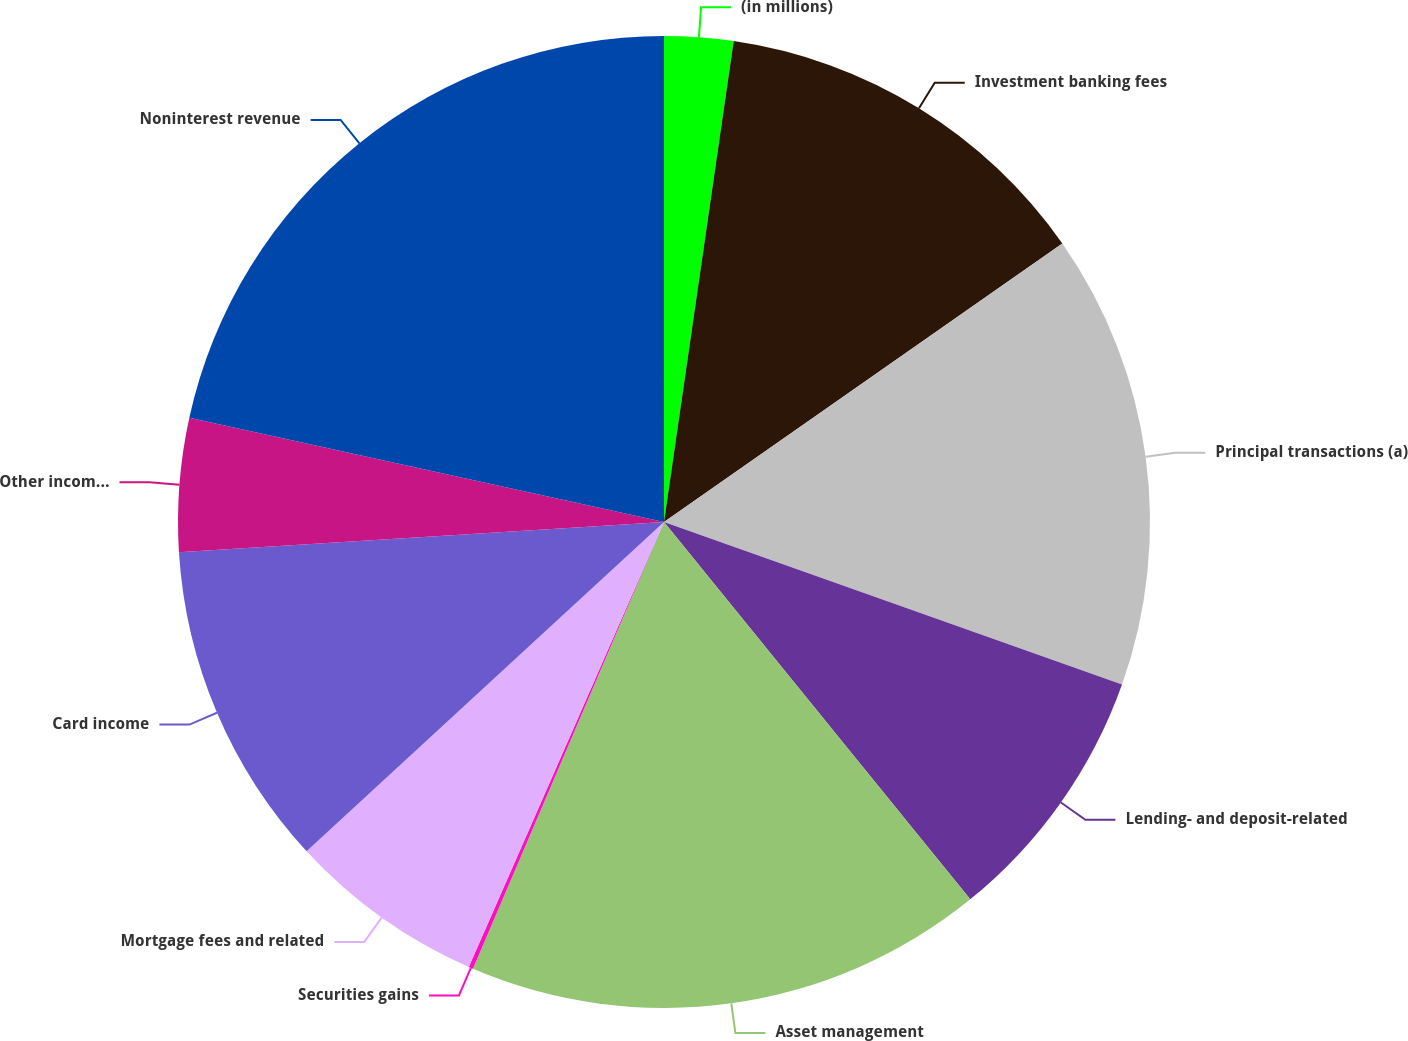Convert chart to OTSL. <chart><loc_0><loc_0><loc_500><loc_500><pie_chart><fcel>(in millions)<fcel>Investment banking fees<fcel>Principal transactions (a)<fcel>Lending- and deposit-related<fcel>Asset management<fcel>Securities gains<fcel>Mortgage fees and related<fcel>Card income<fcel>Other income (b)<fcel>Noninterest revenue<nl><fcel>2.29%<fcel>13.0%<fcel>15.14%<fcel>8.72%<fcel>17.28%<fcel>0.15%<fcel>6.57%<fcel>10.86%<fcel>4.43%<fcel>21.56%<nl></chart> 